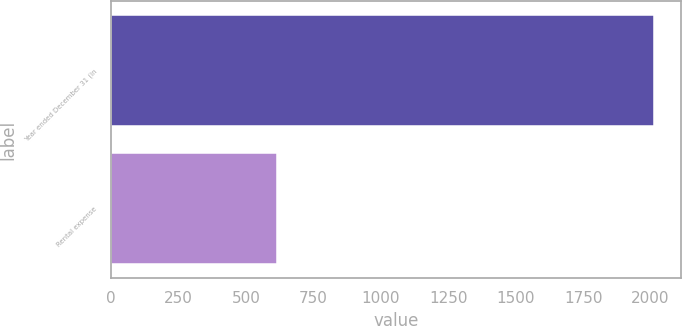Convert chart. <chart><loc_0><loc_0><loc_500><loc_500><bar_chart><fcel>Year ended December 31 (in<fcel>Rental expense<nl><fcel>2013<fcel>616<nl></chart> 